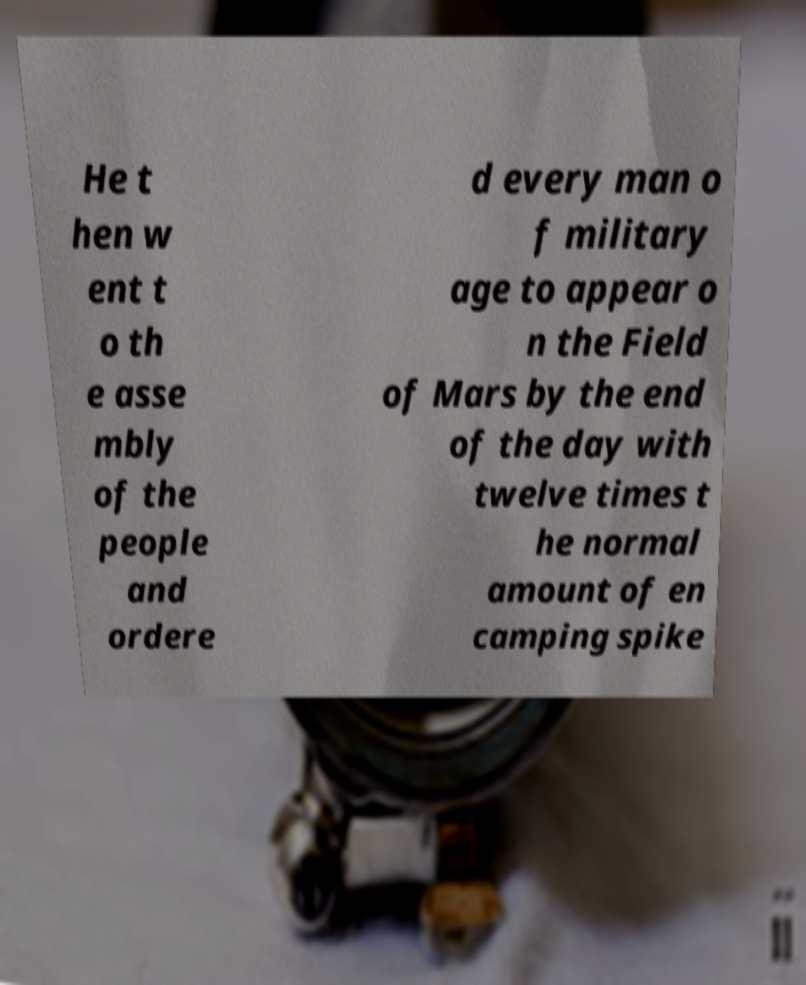For documentation purposes, I need the text within this image transcribed. Could you provide that? He t hen w ent t o th e asse mbly of the people and ordere d every man o f military age to appear o n the Field of Mars by the end of the day with twelve times t he normal amount of en camping spike 